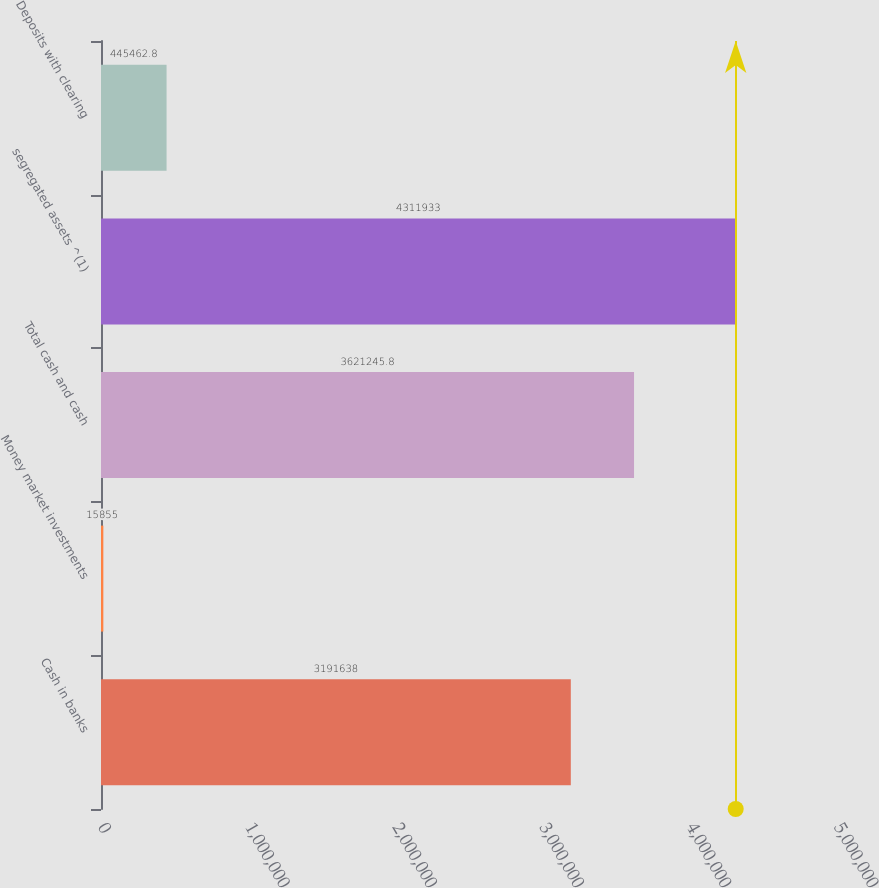<chart> <loc_0><loc_0><loc_500><loc_500><bar_chart><fcel>Cash in banks<fcel>Money market investments<fcel>Total cash and cash<fcel>segregated assets ^(1)<fcel>Deposits with clearing<nl><fcel>3.19164e+06<fcel>15855<fcel>3.62125e+06<fcel>4.31193e+06<fcel>445463<nl></chart> 